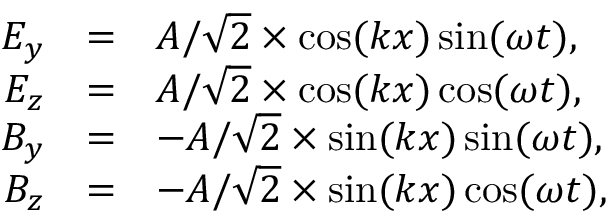<formula> <loc_0><loc_0><loc_500><loc_500>\begin{array} { r c l } { E _ { y } } & { = } & { A / \sqrt { 2 } \times \cos ( k x ) \sin ( \omega t ) , } \\ { E _ { z } } & { = } & { A / \sqrt { 2 } \times \cos ( k x ) \cos ( \omega t ) , } \\ { B _ { y } } & { = } & { - A / \sqrt { 2 } \times \sin ( k x ) \sin ( \omega t ) , } \\ { B _ { z } } & { = } & { - A / \sqrt { 2 } \times \sin ( k x ) \cos ( \omega t ) , } \end{array}</formula> 